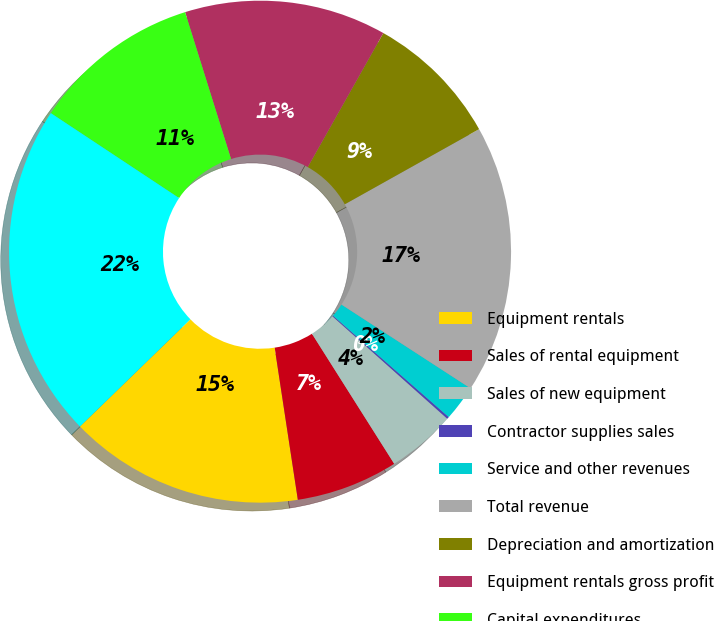<chart> <loc_0><loc_0><loc_500><loc_500><pie_chart><fcel>Equipment rentals<fcel>Sales of rental equipment<fcel>Sales of new equipment<fcel>Contractor supplies sales<fcel>Service and other revenues<fcel>Total revenue<fcel>Depreciation and amortization<fcel>Equipment rentals gross profit<fcel>Capital expenditures<fcel>Total assets (1)<nl><fcel>15.14%<fcel>6.57%<fcel>4.43%<fcel>0.14%<fcel>2.29%<fcel>17.28%<fcel>8.71%<fcel>13.0%<fcel>10.86%<fcel>21.57%<nl></chart> 